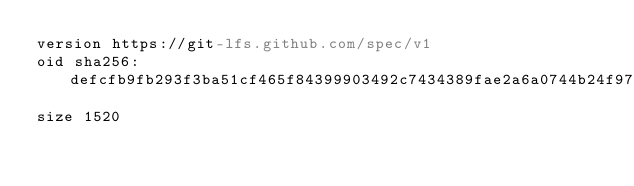<code> <loc_0><loc_0><loc_500><loc_500><_YAML_>version https://git-lfs.github.com/spec/v1
oid sha256:defcfb9fb293f3ba51cf465f84399903492c7434389fae2a6a0744b24f97bb0d
size 1520
</code> 